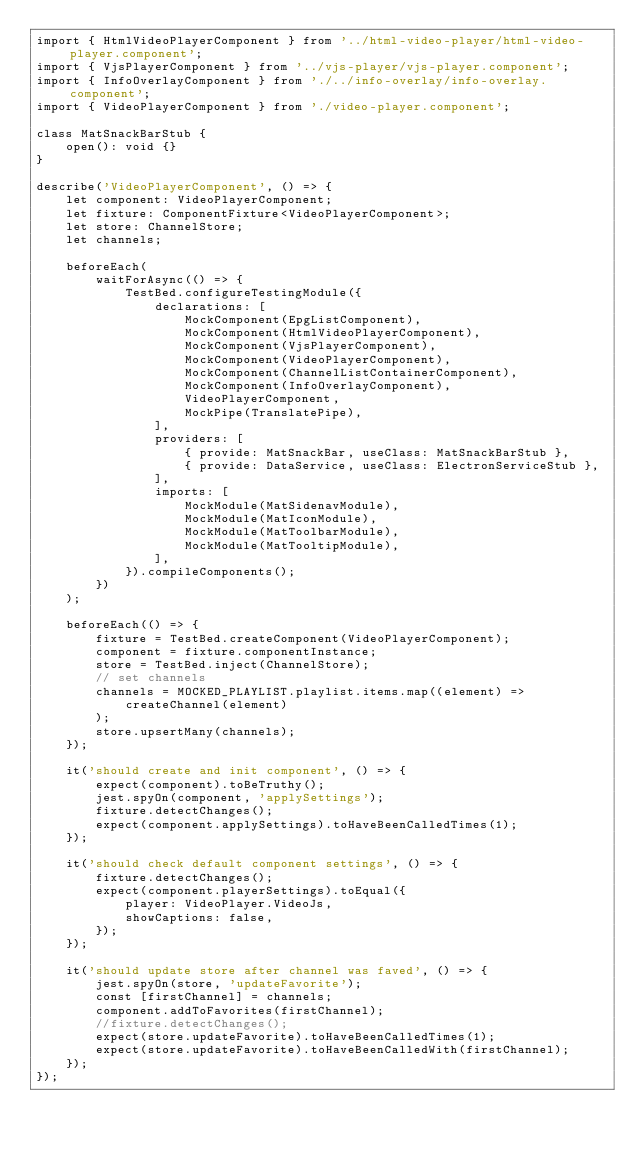Convert code to text. <code><loc_0><loc_0><loc_500><loc_500><_TypeScript_>import { HtmlVideoPlayerComponent } from '../html-video-player/html-video-player.component';
import { VjsPlayerComponent } from '../vjs-player/vjs-player.component';
import { InfoOverlayComponent } from './../info-overlay/info-overlay.component';
import { VideoPlayerComponent } from './video-player.component';

class MatSnackBarStub {
    open(): void {}
}

describe('VideoPlayerComponent', () => {
    let component: VideoPlayerComponent;
    let fixture: ComponentFixture<VideoPlayerComponent>;
    let store: ChannelStore;
    let channels;

    beforeEach(
        waitForAsync(() => {
            TestBed.configureTestingModule({
                declarations: [
                    MockComponent(EpgListComponent),
                    MockComponent(HtmlVideoPlayerComponent),
                    MockComponent(VjsPlayerComponent),
                    MockComponent(VideoPlayerComponent),
                    MockComponent(ChannelListContainerComponent),
                    MockComponent(InfoOverlayComponent),
                    VideoPlayerComponent,
                    MockPipe(TranslatePipe),
                ],
                providers: [
                    { provide: MatSnackBar, useClass: MatSnackBarStub },
                    { provide: DataService, useClass: ElectronServiceStub },
                ],
                imports: [
                    MockModule(MatSidenavModule),
                    MockModule(MatIconModule),
                    MockModule(MatToolbarModule),
                    MockModule(MatTooltipModule),
                ],
            }).compileComponents();
        })
    );

    beforeEach(() => {
        fixture = TestBed.createComponent(VideoPlayerComponent);
        component = fixture.componentInstance;
        store = TestBed.inject(ChannelStore);
        // set channels
        channels = MOCKED_PLAYLIST.playlist.items.map((element) =>
            createChannel(element)
        );
        store.upsertMany(channels);
    });

    it('should create and init component', () => {
        expect(component).toBeTruthy();
        jest.spyOn(component, 'applySettings');
        fixture.detectChanges();
        expect(component.applySettings).toHaveBeenCalledTimes(1);
    });

    it('should check default component settings', () => {
        fixture.detectChanges();
        expect(component.playerSettings).toEqual({
            player: VideoPlayer.VideoJs,
            showCaptions: false,
        });
    });

    it('should update store after channel was faved', () => {
        jest.spyOn(store, 'updateFavorite');
        const [firstChannel] = channels;
        component.addToFavorites(firstChannel);
        //fixture.detectChanges();
        expect(store.updateFavorite).toHaveBeenCalledTimes(1);
        expect(store.updateFavorite).toHaveBeenCalledWith(firstChannel);
    });
});
</code> 